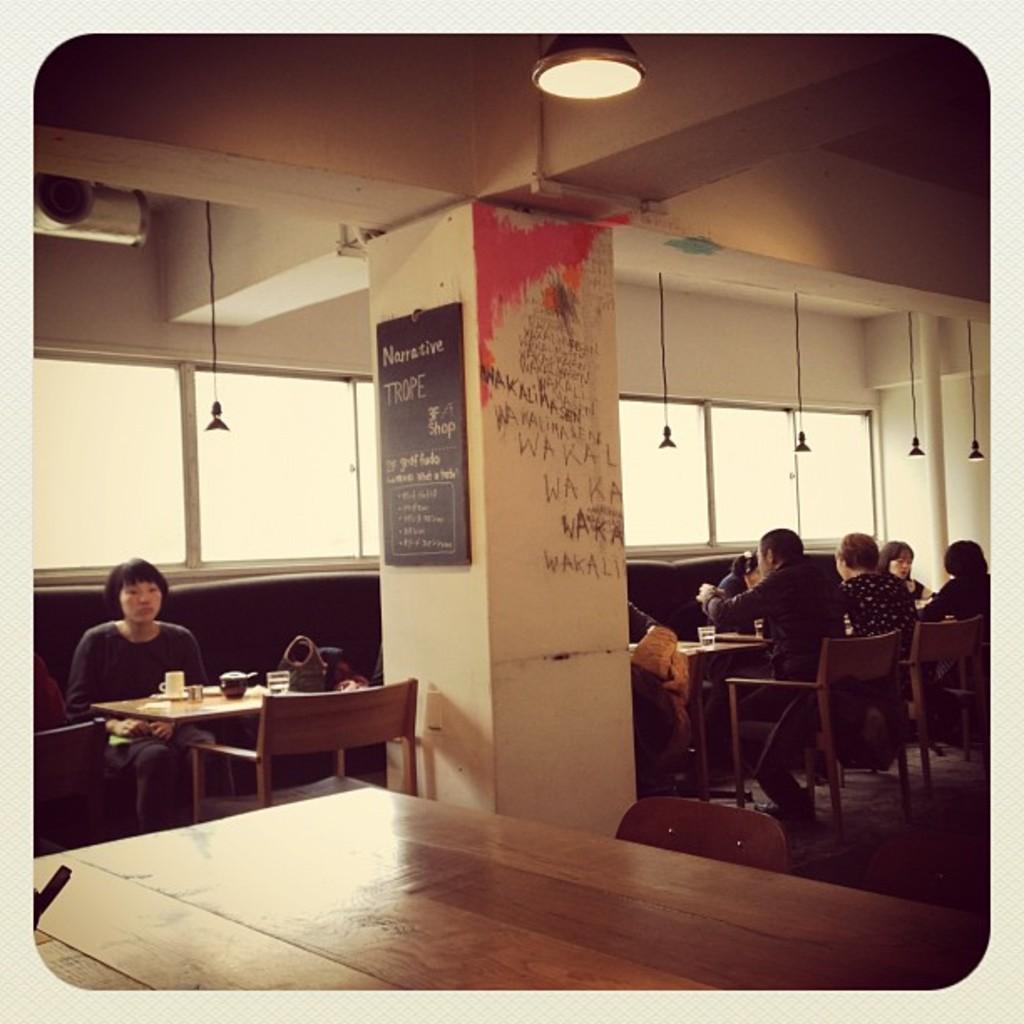Describe this image in one or two sentences. In the image we can see there are people wearing clothes, they are sitting on the chair. There are tables, on the table there are many other objects. Here we can see a pillar, black board and text on the board. This is a floor, glass windows and lights. 